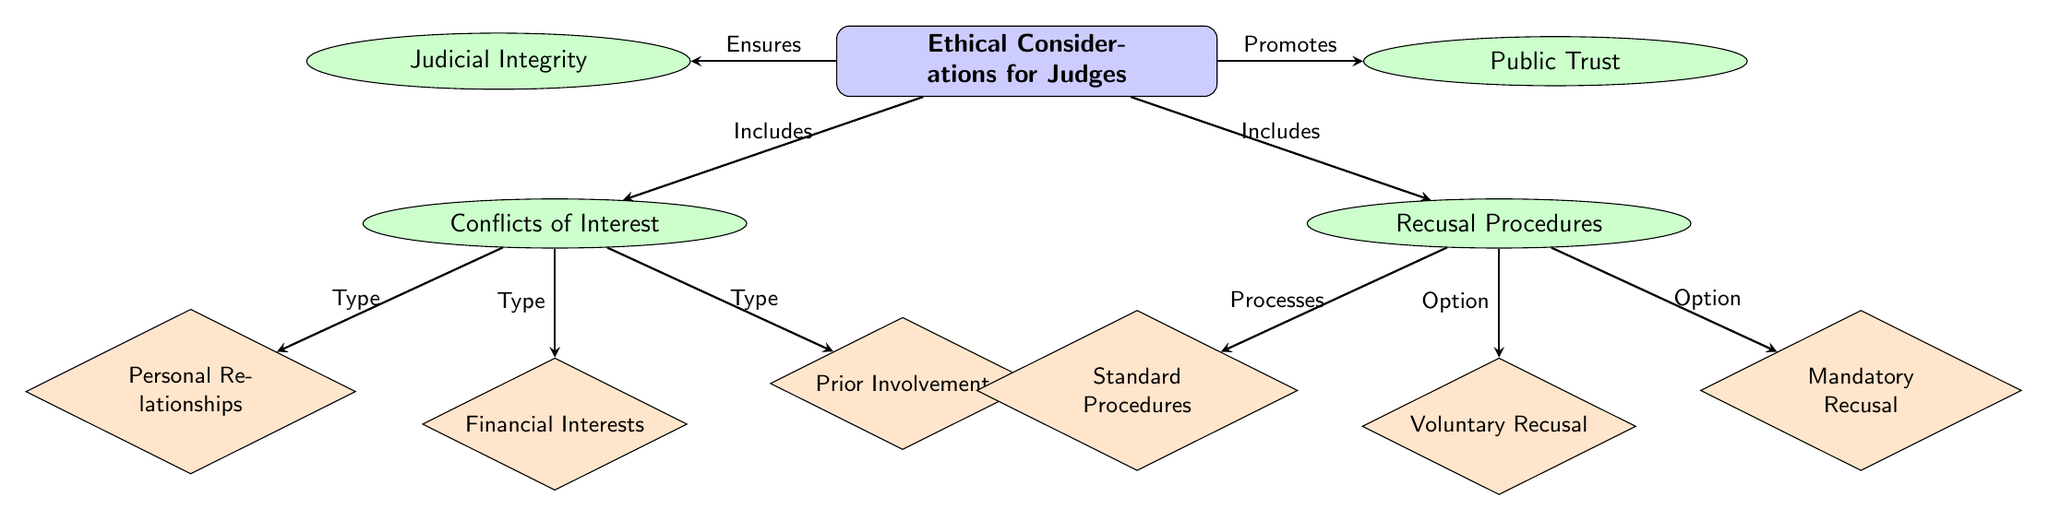What are the two main categories of ethical considerations for judges? The diagram's main node specifically states "Ethical Considerations for Judges" which is directly connected to two sub-nodes: "Conflicts of Interest" and "Recusal Procedures." Therefore, the two main categories are identified as those two.
Answer: Conflicts of Interest, Recusal Procedures How many types of conflicts of interest are depicted in the diagram? Looking at the sub-nodes branching from "Conflicts of Interest," there are three distinct types listed: "Personal Relationships," "Financial Interests," and "Prior Involvement." Counting these, we arrive at the total.
Answer: 3 What does the diagram indicate as the impact of ethical considerations on judicial integrity? The diagram shows a connection from the main node "Ethical Considerations for Judges" to the node "Judicial Integrity" with the label "Ensures." This suggests that ethical considerations play a crucial role in ensuring judicial integrity.
Answer: Ensures Which recusal procedure provides judges the option to step down voluntarily? The diagram reveals that "Voluntary Recusal" is one of the processes listed under the "Recusal Procedures" node. It is specifically labeled as an option for judges who choose to recuse themselves.
Answer: Voluntary Recusal What are the three specific options for recusal procedures listed in the diagram? The diagram outlines "Standard Procedures," "Voluntary Recusal," and "Mandatory Recusal" as the three options. These are all directly connected to the "Recusal Procedures" node, thus providing the specific options available.
Answer: Standard Procedures, Voluntary Recusal, Mandatory Recusal How does the diagram illustrate the relationship between ethical considerations and public trust? According to the diagram, there is a directed line from the "Ethical Considerations for Judges" node to the "Public Trust" node, labeled "Promotes." This indicates that ethical considerations serve to promote public trust in the judicial system.
Answer: Promotes What type of relationship can create conflicts of interest according to the diagram? The diagram explicitly lists "Personal Relationships" under the "Conflicts of Interest" node, indicating that personal relationships are a category that can lead to such conflicts.
Answer: Personal Relationships Which type of interest is considered a conflict as per the diagram? The diagram includes "Financial Interests" as one of the types under "Conflicts of Interest," indicating that financial interests are specifically noted as a conflict.
Answer: Financial Interests 